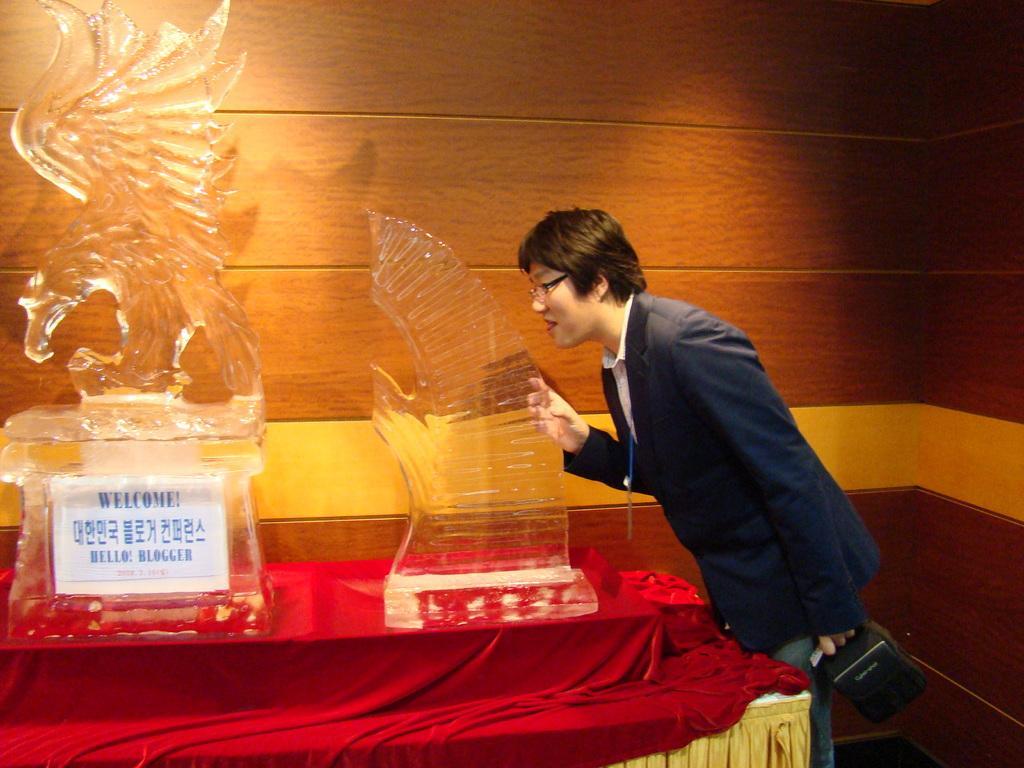Can you describe this image briefly? This is the man standing. He wore a suit, shirt and trouser. I think these are the glass sculptures, which are placed on the table. This table is covered with red color cloth. This is the wall. 